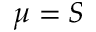<formula> <loc_0><loc_0><loc_500><loc_500>\mu = S</formula> 